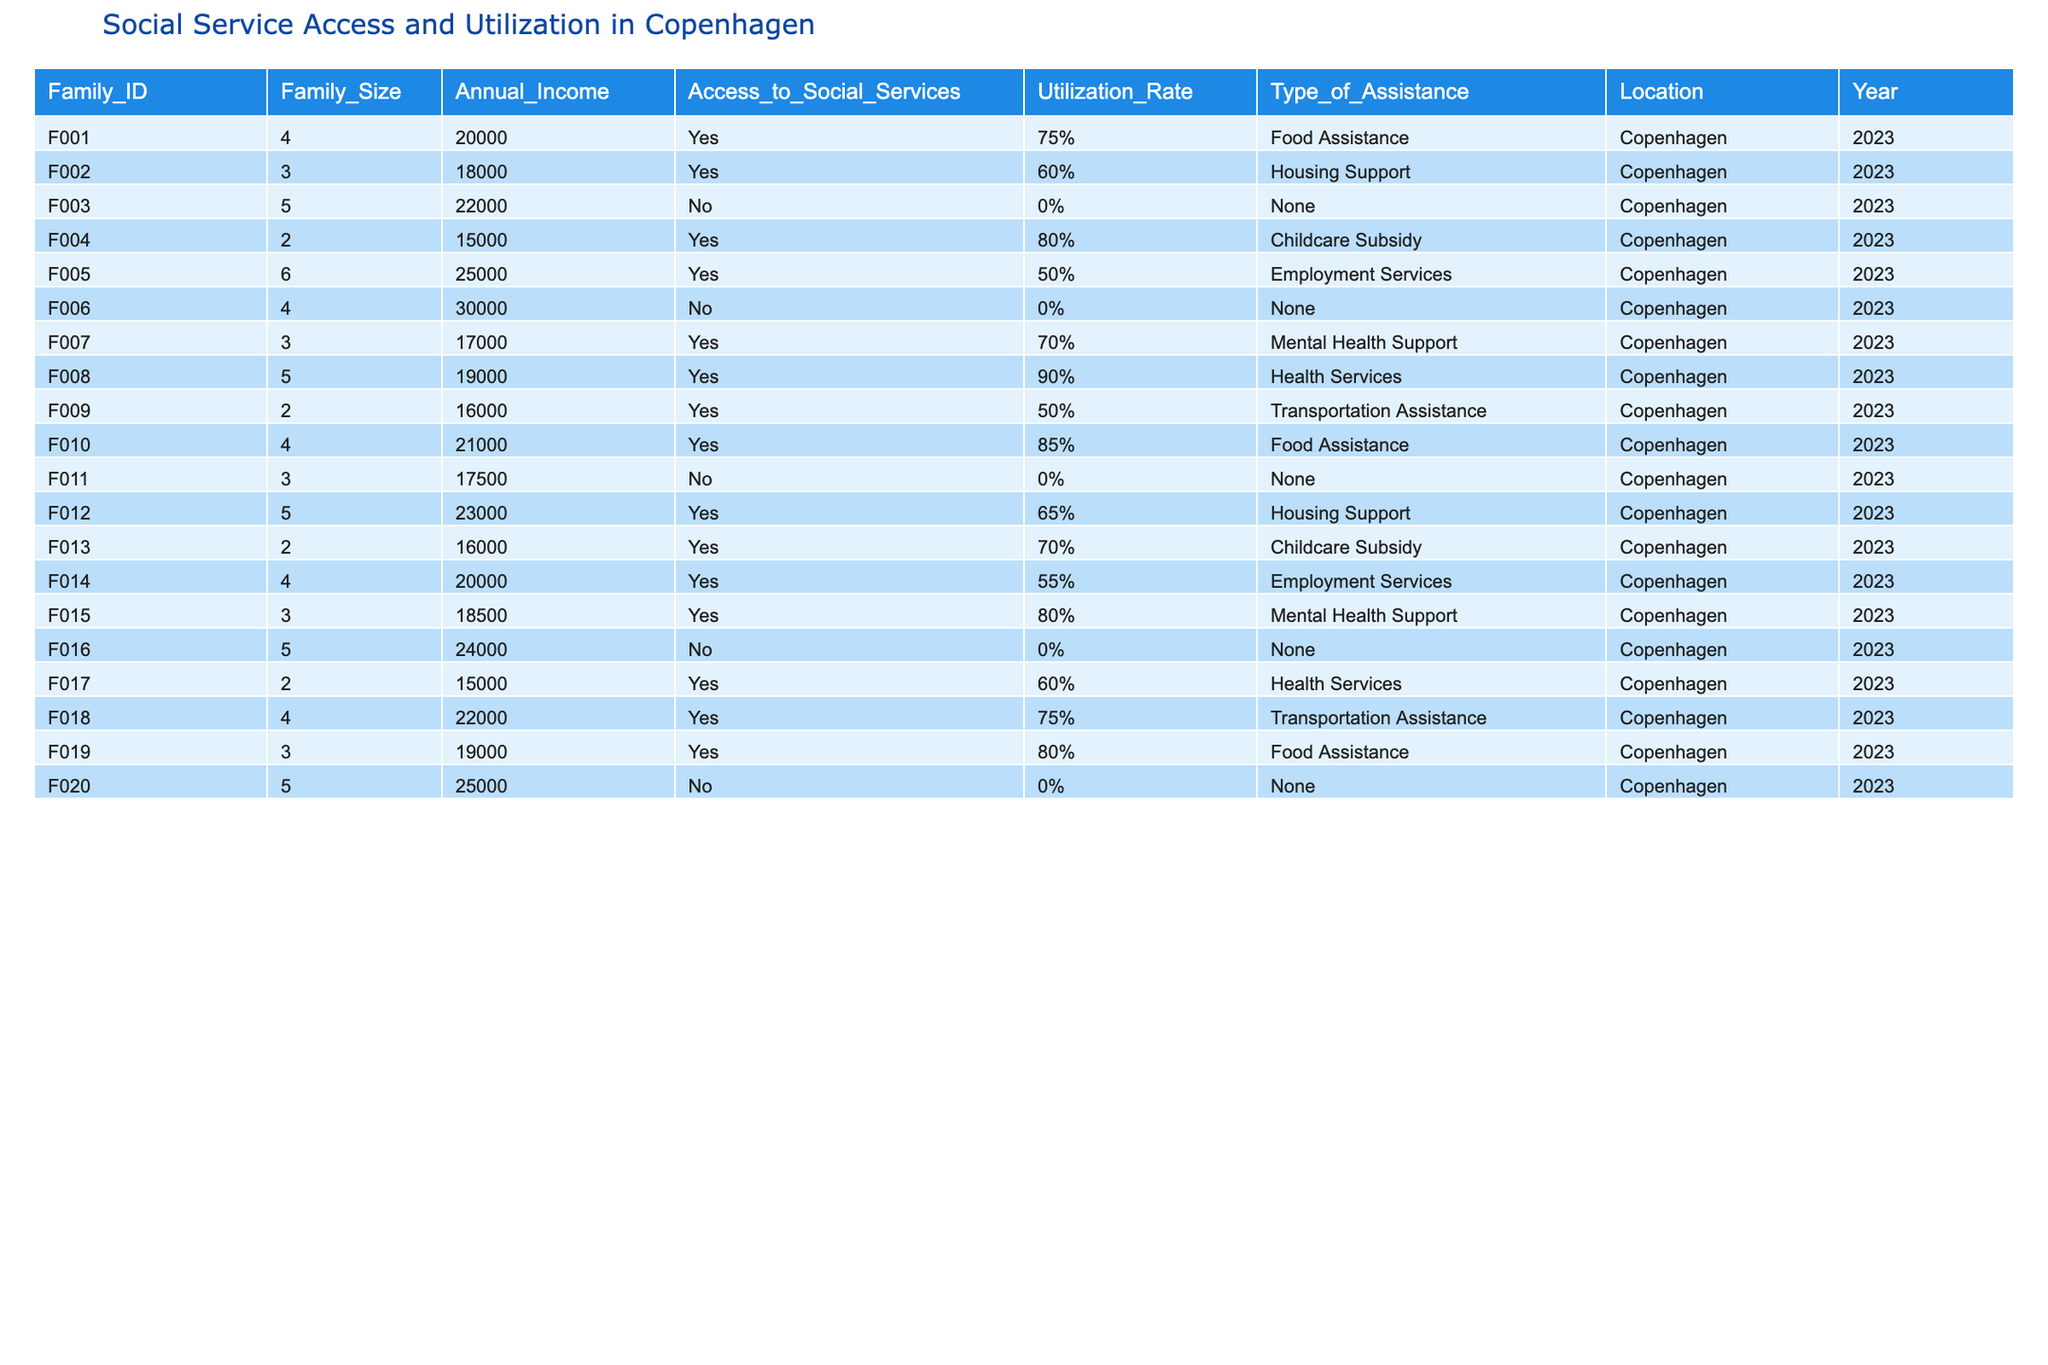What is the utilization rate for families that access food assistance? There are two families accessing food assistance: Family F001 with a utilization rate of 75% and Family F010 with a utilization rate of 85%. To find the average, we take (75% + 85%) / 2 = 80%.
Answer: 80% How many families accessed social services in 2023? Reviewing the table, we see 14 families have 'Yes' under Access to Social Services.
Answer: 14 What type of assistance did Family F007 receive? Looking at Family F007 in the table, it shows that they received Mental Health Support.
Answer: Mental Health Support What percentage of families with annual income below 20,000 had access to social services? Families with income below 20,000 are F002, F004, F007, F009, F011, F013, and F015. Out of these, F002, F004, F007, F009, F013, and F015 accessed social services. That's 6 out of 7. Thus, the percentage is (6/7) * 100 = approximately 85.71%.
Answer: 85.71% Which family had the lowest utilization rate among those that accessed housing support? The table shows two families accessed housing support: Family F002 with 60% utilization and Family F012 with 65%. Therefore, Family F002 has the lowest utilization rate.
Answer: Family F002 What is the average family size of those who did not access any social services? Families F003, F006, F011, F016, and F020 did not access services, with sizes 5, 4, 3, 5, and 5 respectively. The average size calculation is (5 + 4 + 3 + 5 + 5) / 5 = 4.4.
Answer: 4.4 Which type of assistance had the highest average utilization rate? The types of assistance and their rates are as follows: Food Assistance: (75% + 85%)/2 = 80%, Housing Support: (60% + 65%)/2 = 62.5%, Childcare Subsidy: (80% + 70%)/2 = 75%, Employment Services: (50% + 55%)/2 = 52.5%, Mental Health Support: (70% + 80%)/2 = 75%, Health Services: (90% + 60%)/2 = 75%, Transportation Assistance: (50% + 75%)/2 = 62.5%. Food Assistance has the highest average at 80%.
Answer: Food Assistance Are there any families with a size of 2 who did not access social services? Referring to the table, the families with a size of 2 are F004, F013, and F017. Among these, only F017 accessed social services, so there are no families with a size of 2 that did not access services.
Answer: No How many families utilized social services at a rate above 70%? The families with utilization rates above 70% are F001 (75%), F004 (80%), F008 (90%), F010 (85%), F012 (75%), F015 (80%), and F019 (80%). That is a total of 7 families.
Answer: 7 Is there a trend in access to social services based on family income? By reviewing the table, families with annual incomes under 20,000 generally have access to social services, while families with incomes above 20,000 often have positions that show lower access rates (e.g., F003, F006, F016, F020). Therefore, a trend suggests that lower income is generally associated with higher access to social services.
Answer: Yes 